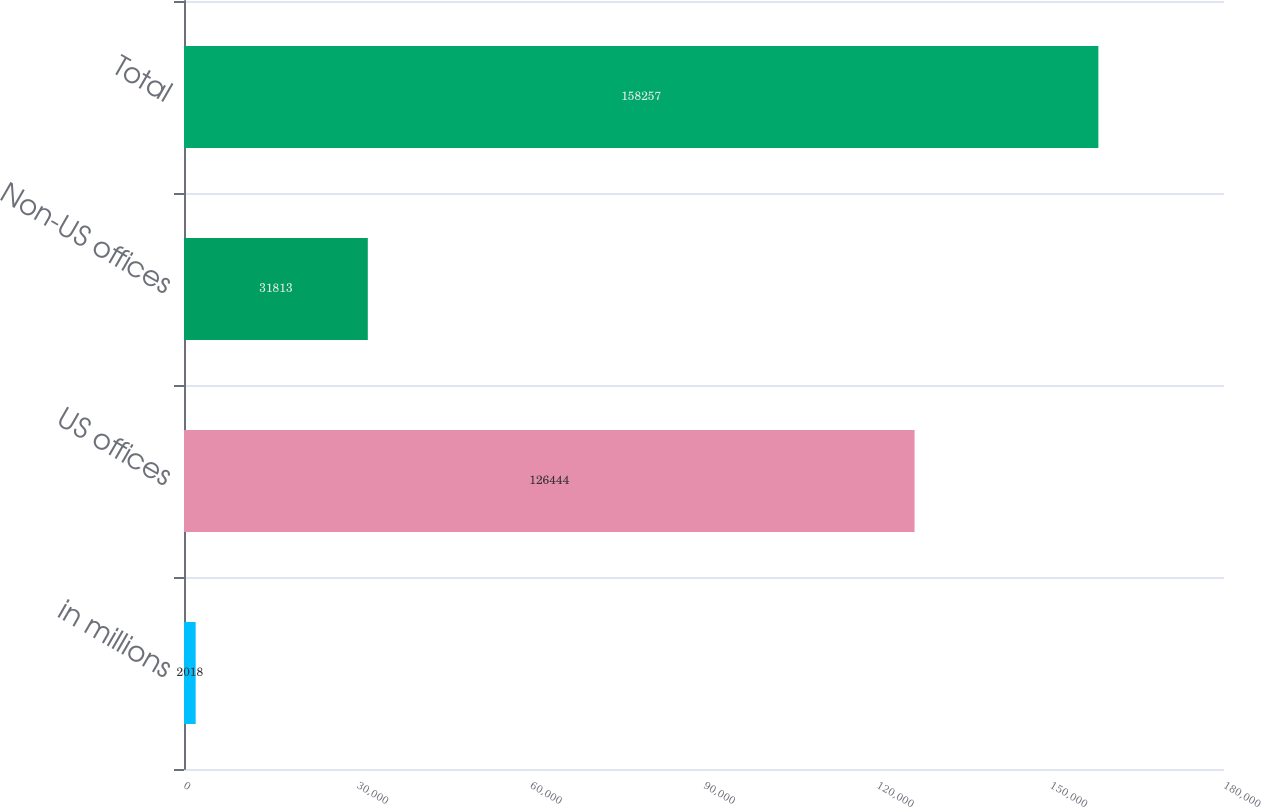Convert chart to OTSL. <chart><loc_0><loc_0><loc_500><loc_500><bar_chart><fcel>in millions<fcel>US offices<fcel>Non-US offices<fcel>Total<nl><fcel>2018<fcel>126444<fcel>31813<fcel>158257<nl></chart> 